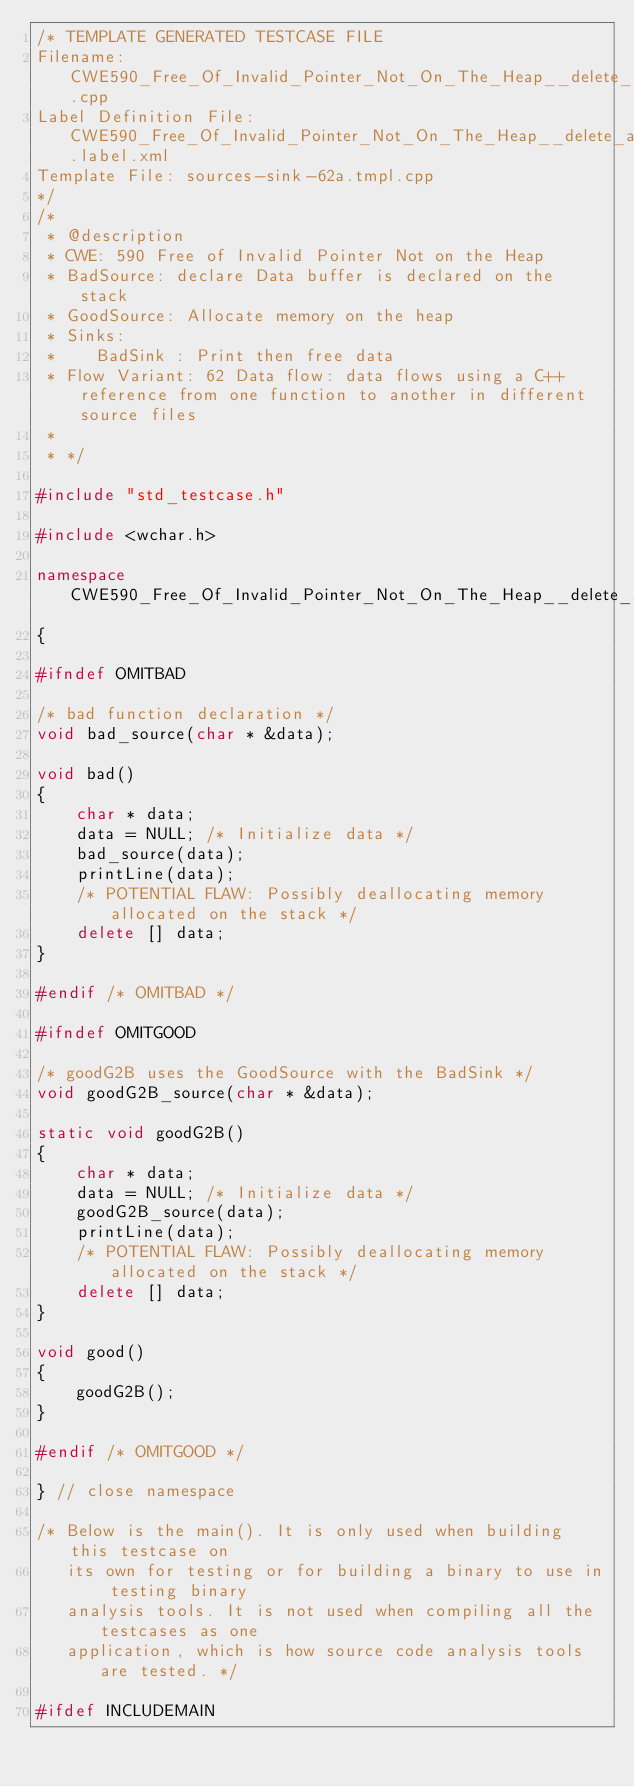Convert code to text. <code><loc_0><loc_0><loc_500><loc_500><_C++_>/* TEMPLATE GENERATED TESTCASE FILE
Filename: CWE590_Free_Of_Invalid_Pointer_Not_On_The_Heap__delete_array_char_declare_62a.cpp
Label Definition File: CWE590_Free_Of_Invalid_Pointer_Not_On_The_Heap__delete_array.label.xml
Template File: sources-sink-62a.tmpl.cpp
*/
/*
 * @description
 * CWE: 590 Free of Invalid Pointer Not on the Heap
 * BadSource: declare Data buffer is declared on the stack
 * GoodSource: Allocate memory on the heap
 * Sinks:
 *    BadSink : Print then free data
 * Flow Variant: 62 Data flow: data flows using a C++ reference from one function to another in different source files
 *
 * */

#include "std_testcase.h"

#include <wchar.h>

namespace CWE590_Free_Of_Invalid_Pointer_Not_On_The_Heap__delete_array_char_declare_62
{

#ifndef OMITBAD

/* bad function declaration */
void bad_source(char * &data);

void bad()
{
    char * data;
    data = NULL; /* Initialize data */
    bad_source(data);
    printLine(data);
    /* POTENTIAL FLAW: Possibly deallocating memory allocated on the stack */
    delete [] data;
}

#endif /* OMITBAD */

#ifndef OMITGOOD

/* goodG2B uses the GoodSource with the BadSink */
void goodG2B_source(char * &data);

static void goodG2B()
{
    char * data;
    data = NULL; /* Initialize data */
    goodG2B_source(data);
    printLine(data);
    /* POTENTIAL FLAW: Possibly deallocating memory allocated on the stack */
    delete [] data;
}

void good()
{
    goodG2B();
}

#endif /* OMITGOOD */

} // close namespace

/* Below is the main(). It is only used when building this testcase on
   its own for testing or for building a binary to use in testing binary
   analysis tools. It is not used when compiling all the testcases as one
   application, which is how source code analysis tools are tested. */

#ifdef INCLUDEMAIN
</code> 